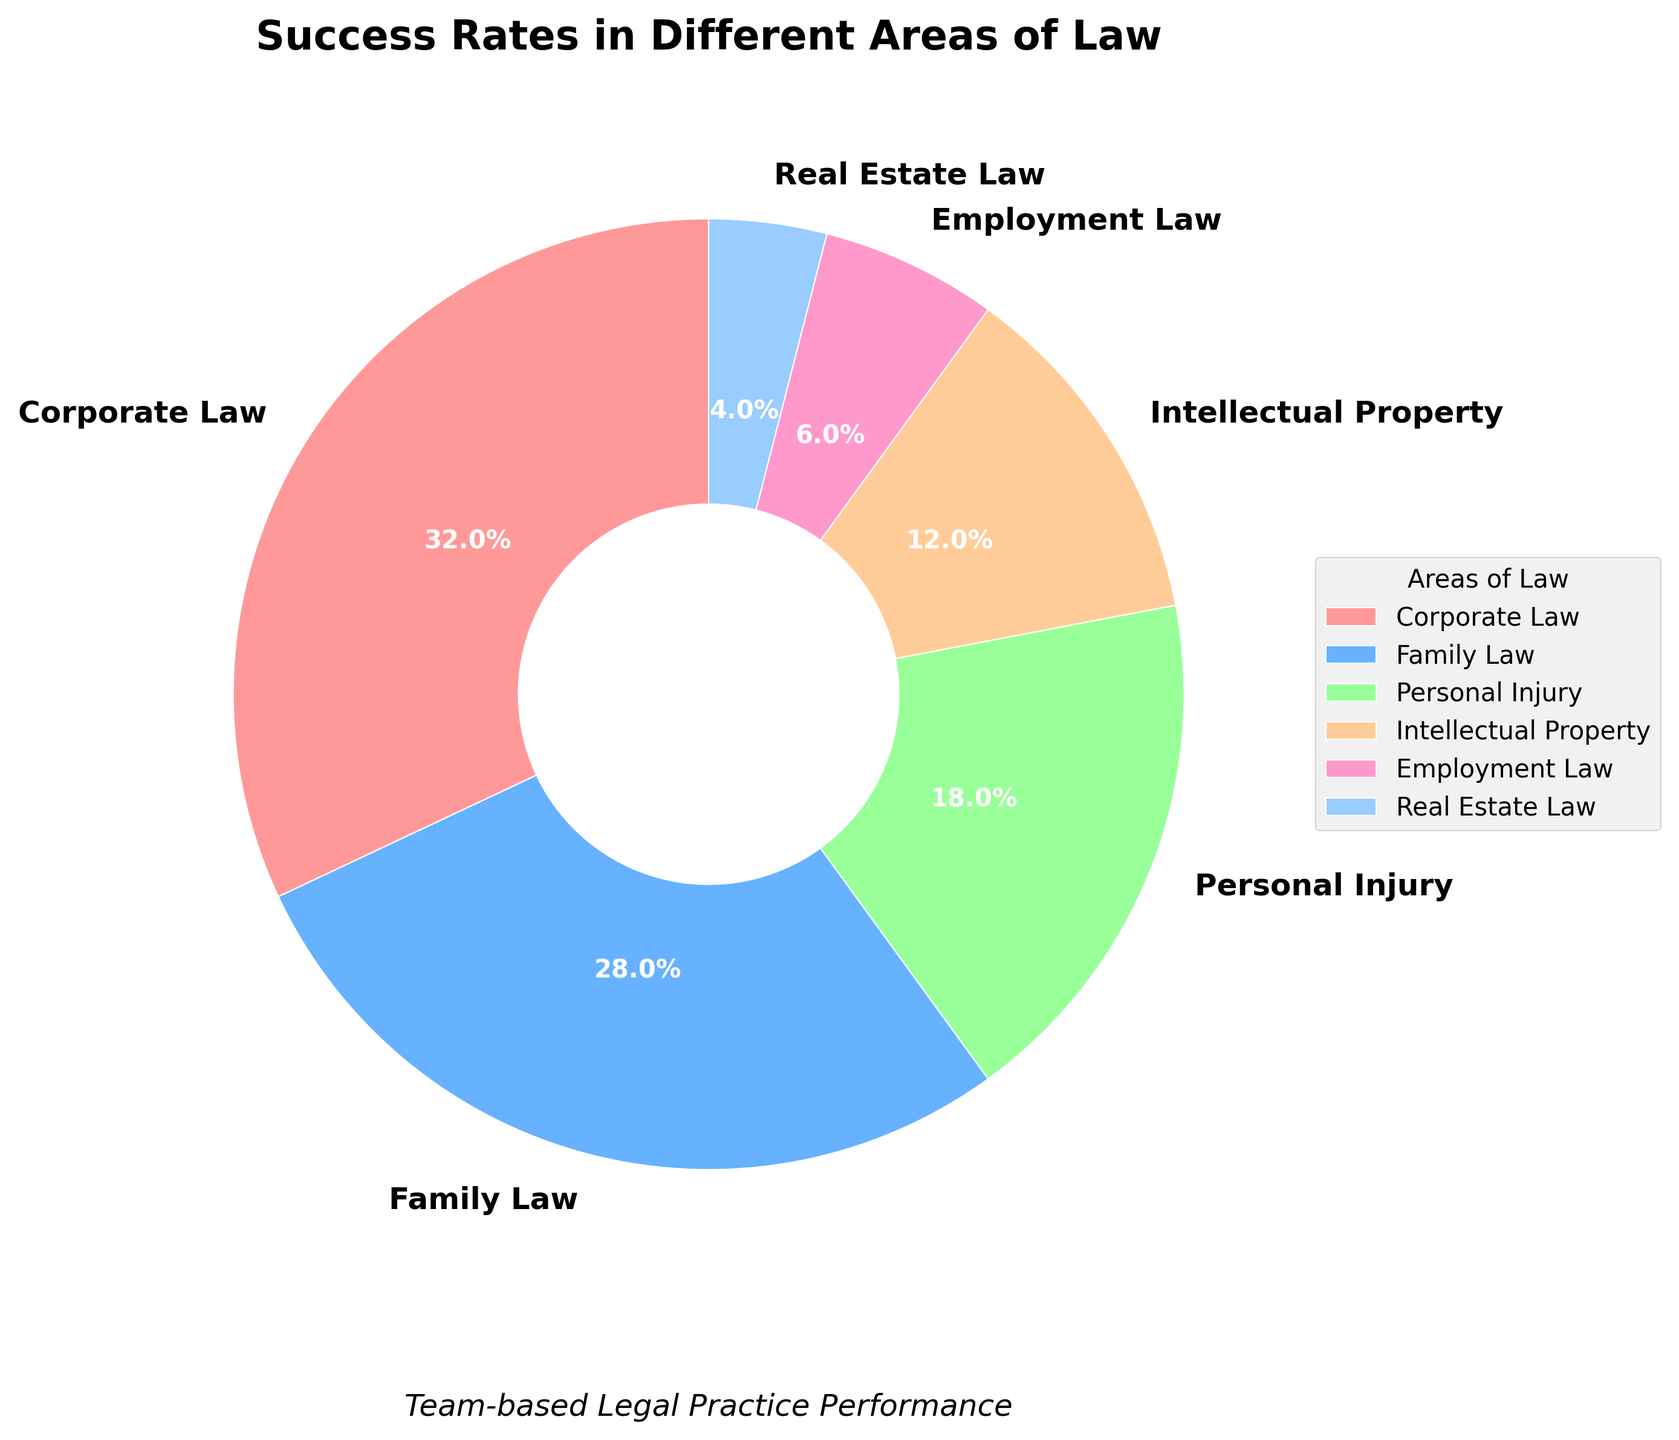Which area of law has the highest success rate? By looking at the pie chart, we observe that Corporate Law has the largest slice. The label indicates a success rate of 32%.
Answer: Corporate Law Which areas of law combined make up over half of the success rates? To determine this, we add the success rates for the largest areas until we reach more than 50%. Corporate Law (32%) + Family Law (28%) equals 60%, which is over half.
Answer: Corporate Law and Family Law What is the combined success rate of Personal Injury and Intellectual Property? The success rates for Personal Injury and Intellectual Property are 18% and 12% respectively. Adding these gives us 18% + 12% = 30%.
Answer: 30% Which area of law has the smallest success rate, and what is it? The pie chart shows that Real Estate Law has the smallest slice. The label indicates a success rate of 4%.
Answer: Real Estate Law, 4% How does the success rate in Employment Law compare to that in Family Law? Employment Law has a success rate of 6%, while Family Law has a much higher rate of 28%. Therefore, Family Law's success rate is significantly higher than Employment Law's.
Answer: Family Law's rate is higher What is the average success rate across all areas of law? To find the average, we sum all success rates and divide by the number of areas. The sum is 32% + 28% + 18% + 12% + 6% + 4% = 100%. The number of areas is 6. Thus, the average success rate is 100% / 6 ≈ 16.67%.
Answer: 16.67% What percent of success rates are covered by the three most successful areas of law? The three areas with the highest success rates are Corporate Law (32%), Family Law (28%), and Personal Injury (18%). Adding these gives us 32% + 28% + 18% = 78%.
Answer: 78% Which area of law has a success rate that is the closest to 10%? The pie chart indicates Intellectual Property with a success rate of 12%, which is the closest to 10%.
Answer: Intellectual Property List the areas of law from highest to lowest success rate. By arranging the areas based on their success rates as shown in the pie chart: Corporate Law (32%), Family Law (28%), Personal Injury (18%), Intellectual Property (12%), Employment Law (6%), Real Estate Law (4%).
Answer: Corporate Law, Family Law, Personal Injury, Intellectual Property, Employment Law, Real Estate Law What is the difference in success rates between the highest and lowest areas of law? The difference between the highest (Corporate Law with 32%) and lowest (Real Estate Law with 4%) is calculated as 32% - 4% = 28%.
Answer: 28% 